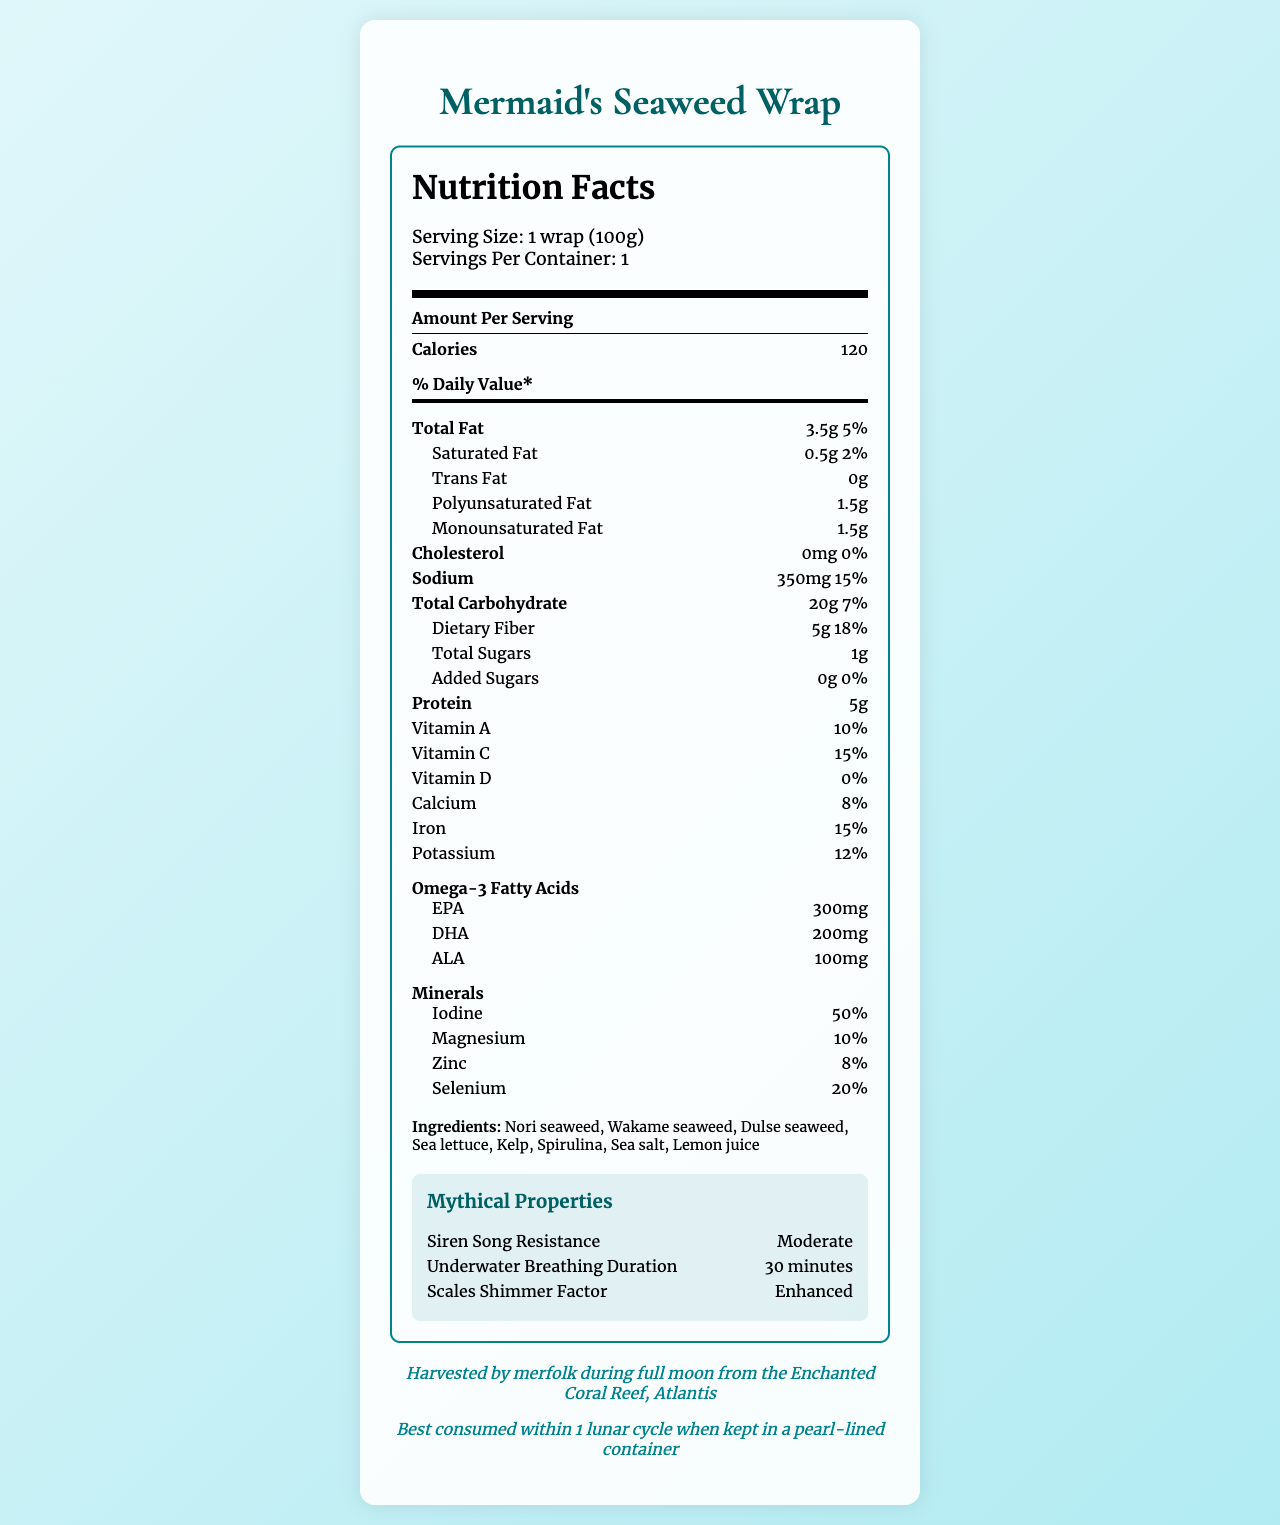what is the serving size? The serving size is stated in the serving info section as "Serving Size: 1 wrap (100g)".
Answer: 1 wrap (100g) how many calories are in one serving of Mermaid's Seaweed Wrap? The nutrition label lists the calories per serving as 120.
Answer: 120 what is the total fat content in one serving? The total fat content is listed as 3.5g under the "Total Fat" section.
Answer: 3.5g how much iodine does the wrap provide as a percentage of daily value? The iodine content is listed under the minerals section as 50%.
Answer: 50% identify one ingredient used in the wrap. Sea lettuce is listed among the ingredients.
Answer: Sea lettuce which of the following is NOT a mineral found in the wrap? A. Iodine B. Selenium C. Copper D. Zinc The minerals listed are iodine, selenium, magnesium, and zinc. Copper is not mentioned.
Answer: C. Copper how much protein is in one serving of the wrap? A. 3g B. 5g C. 10g D. 15g The protein content is listed as 5g.
Answer: B. 5g which omega-3 fatty acid is present in the smallest amount? A. EPA B. DHA C. ALA ALA is listed at 100mg, whereas EPA and DHA are higher.
Answer: C. ALA does the wrap contain any cholesterol? The cholesterol content is listed as 0mg in the document.
Answer: No what is the document mainly about? The document is focused on presenting the complete nutritional facts, ingredients, and other specific details about the Mermaid's Seaweed Wrap.
Answer: The document provides the nutritional composition and other relevant details of Mermaid's Seaweed Wrap, including serving size, calories, fats, carbohydrates, proteins, vitamins, minerals, omega-3 fatty acids, ingredients, mythical properties, and harvesting information. how was the seaweed wrap harvested? The harvesting method is specifically described as "Hand-gathered by merfolk during full moon".
Answer: Hand-gathered by merfolk during full moon what percentage of daily value for vitamin C does the wrap provide? The Vitamin C content is listed as 15% under the vitamins section.
Answer: 15% is there added sugar in the wrap? A. Yes B. No The added sugars content is listed as 0g, implying no added sugars.
Answer: B. No how long can one breathe underwater after consuming the wrap? The underwater breathing duration is listed under the mythical properties section as "30 minutes".
Answer: 30 minutes where is the origin of the Mermaid's Seaweed Wrap? The origin is provided as "Enchanted Coral Reef, Atlantis".
Answer: Enchanted Coral Reef, Atlantis what is the scales shimmer factor of this product as per the document? The scales shimmer factor is stated under mythical properties as "Enhanced".
Answer: Enhanced how much polyunsaturated fat is in the wrap? The polyunsaturated fat content is listed as 1.5g under the fats section.
Answer: 1.5g what is the shelf life of the product? The shelf life is stated as "1 lunar cycle when kept in a pearl-lined container".
Answer: 1 lunar cycle when kept in a pearl-lined container what is the exact weight of EPA and DHA combined in this wrap? EPA is listed as 300mg, and DHA is listed as 200mg; their combined weight is 500mg.
Answer: 500mg what is the amount of carbohydrates in one serving? The total carbohydrate content is listed as 20g under the carbohydrates section.
Answer: 20g is the document specific about the type of container needed for storing the wrap? The document specifies "kept in a pearl-lined container" for shelf life.
Answer: Yes how does the wrap help resist siren songs, based on nutrient composition? The nutrient composition does not explain the mythical property of siren song resistance.
Answer: Cannot be determined 